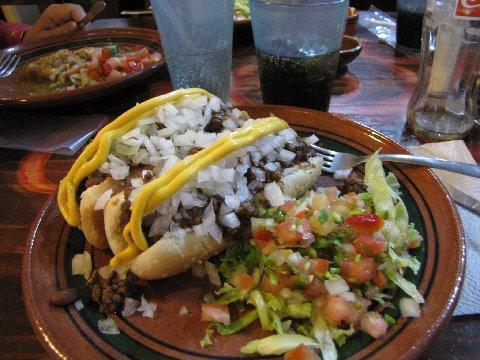Is "The hot dog is touching the person." an appropriate description for the image?
Answer yes or no. No. 